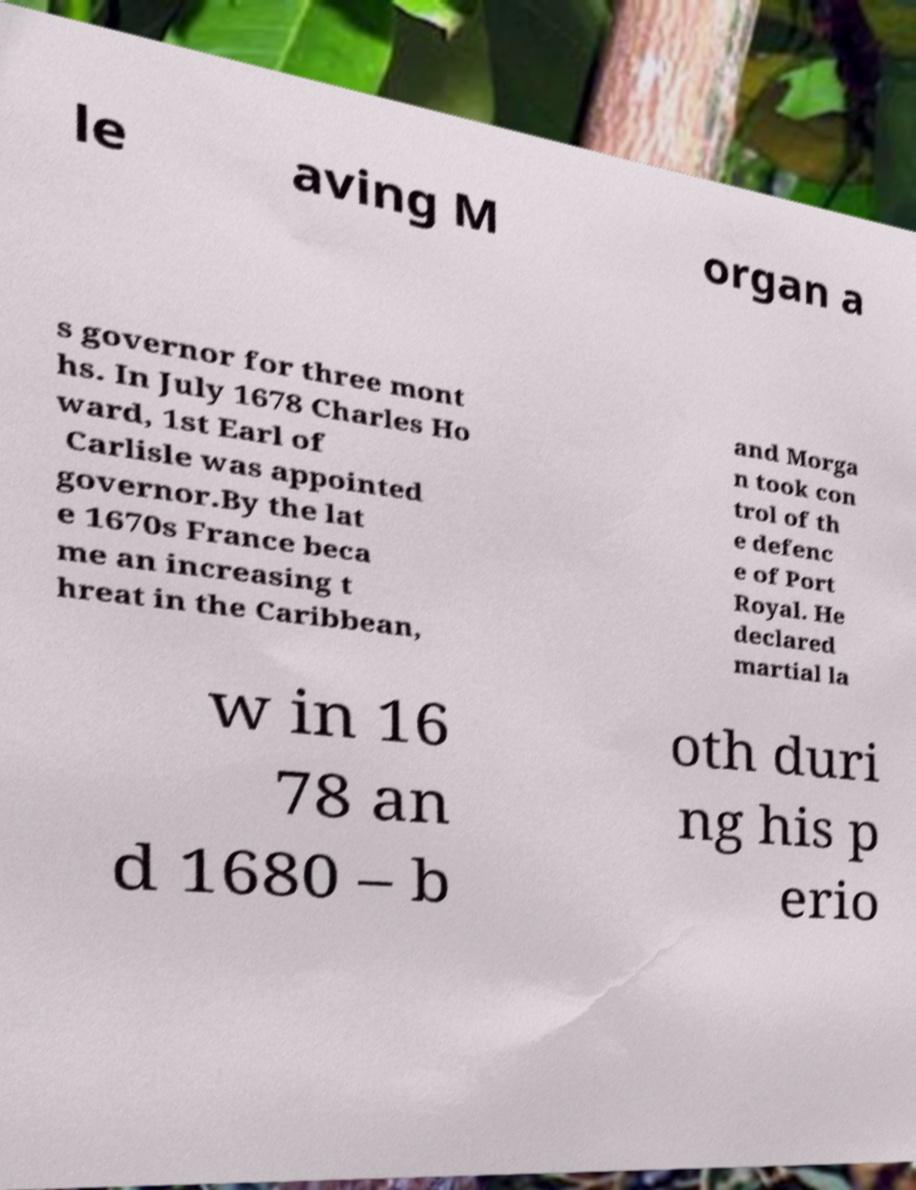I need the written content from this picture converted into text. Can you do that? le aving M organ a s governor for three mont hs. In July 1678 Charles Ho ward, 1st Earl of Carlisle was appointed governor.By the lat e 1670s France beca me an increasing t hreat in the Caribbean, and Morga n took con trol of th e defenc e of Port Royal. He declared martial la w in 16 78 an d 1680 – b oth duri ng his p erio 